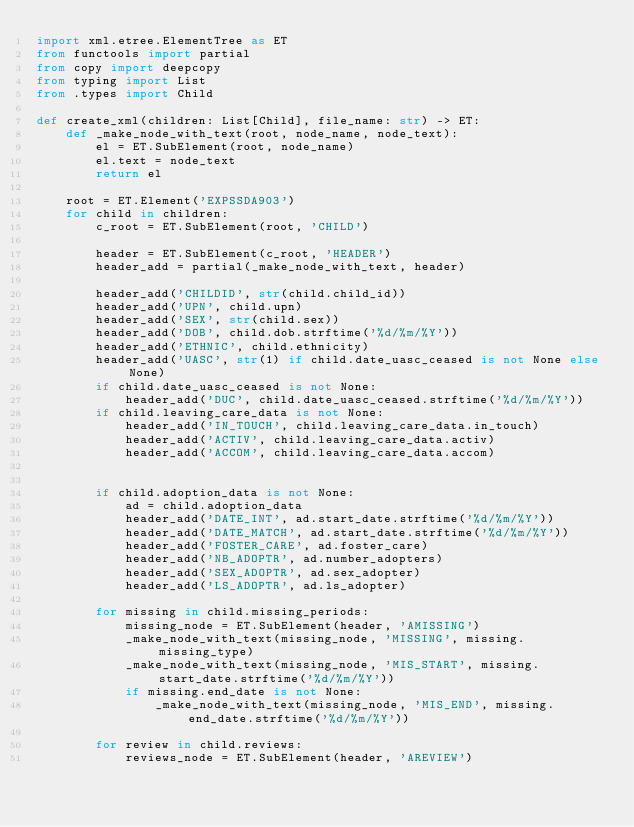<code> <loc_0><loc_0><loc_500><loc_500><_Python_>import xml.etree.ElementTree as ET
from functools import partial
from copy import deepcopy
from typing import List
from .types import Child

def create_xml(children: List[Child], file_name: str) -> ET:
    def _make_node_with_text(root, node_name, node_text):
        el = ET.SubElement(root, node_name)
        el.text = node_text
        return el

    root = ET.Element('EXPSSDA903')
    for child in children:
        c_root = ET.SubElement(root, 'CHILD')

        header = ET.SubElement(c_root, 'HEADER')
        header_add = partial(_make_node_with_text, header)

        header_add('CHILDID', str(child.child_id))
        header_add('UPN', child.upn)
        header_add('SEX', str(child.sex))
        header_add('DOB', child.dob.strftime('%d/%m/%Y'))
        header_add('ETHNIC', child.ethnicity)
        header_add('UASC', str(1) if child.date_uasc_ceased is not None else None)
        if child.date_uasc_ceased is not None:
            header_add('DUC', child.date_uasc_ceased.strftime('%d/%m/%Y'))
        if child.leaving_care_data is not None:
            header_add('IN_TOUCH', child.leaving_care_data.in_touch)
            header_add('ACTIV', child.leaving_care_data.activ)
            header_add('ACCOM', child.leaving_care_data.accom)


        if child.adoption_data is not None:
            ad = child.adoption_data
            header_add('DATE_INT', ad.start_date.strftime('%d/%m/%Y'))
            header_add('DATE_MATCH', ad.start_date.strftime('%d/%m/%Y'))
            header_add('FOSTER_CARE', ad.foster_care)
            header_add('NB_ADOPTR', ad.number_adopters)
            header_add('SEX_ADOPTR', ad.sex_adopter)
            header_add('LS_ADOPTR', ad.ls_adopter)

        for missing in child.missing_periods:
            missing_node = ET.SubElement(header, 'AMISSING')
            _make_node_with_text(missing_node, 'MISSING', missing.missing_type)
            _make_node_with_text(missing_node, 'MIS_START', missing.start_date.strftime('%d/%m/%Y'))
            if missing.end_date is not None:
                _make_node_with_text(missing_node, 'MIS_END', missing.end_date.strftime('%d/%m/%Y'))

        for review in child.reviews:
            reviews_node = ET.SubElement(header, 'AREVIEW')</code> 